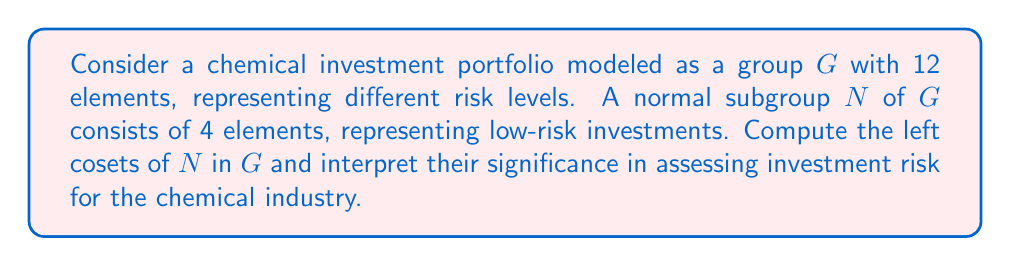Show me your answer to this math problem. Let's approach this step-by-step:

1) First, recall that for a normal subgroup $N$ of $G$, the left cosets are the same as the right cosets. We'll denote a coset as $gN$ where $g \in G$.

2) The number of cosets is given by the index of $N$ in $G$, which is:

   $$[G:N] = \frac{|G|}{|N|} = \frac{12}{4} = 3$$

3) This means there will be 3 distinct cosets, each containing 4 elements.

4) Let's denote the elements of $G$ as $\{g_1, g_2, ..., g_{12}\}$ where $g_1, g_2, g_3, g_4$ are the elements of $N$.

5) The cosets will be:
   
   $N = \{g_1, g_2, g_3, g_4\}$ (the subgroup itself is always a coset)
   $g_5N = \{g_5g_1, g_5g_2, g_5g_3, g_5g_4\}$
   $g_9N = \{g_9g_1, g_9g_2, g_9g_3, g_9g_4\}$

6) In the context of chemical investments:
   - $N$ represents the low-risk investments
   - $g_5N$ could represent medium-risk investments
   - $g_9N$ could represent high-risk investments

7) The coset structure provides a way to categorize investments based on their risk level. Each coset contains investments that are "equivalent" in terms of risk when combined with the low-risk investments in $N$.

8) This coset structure allows for systematic risk assessment and portfolio diversification in chemical industry investments.
Answer: The left cosets of $N$ in $G$ are:

1) $N = \{g_1, g_2, g_3, g_4\}$ (low-risk investments)
2) $g_5N = \{g_5g_1, g_5g_2, g_5g_3, g_5g_4\}$ (medium-risk investments)
3) $g_9N = \{g_9g_1, g_9g_2, g_9g_3, g_9g_4\}$ (high-risk investments)

These cosets provide a structured way to categorize and assess investment risks in the chemical industry portfolio. 